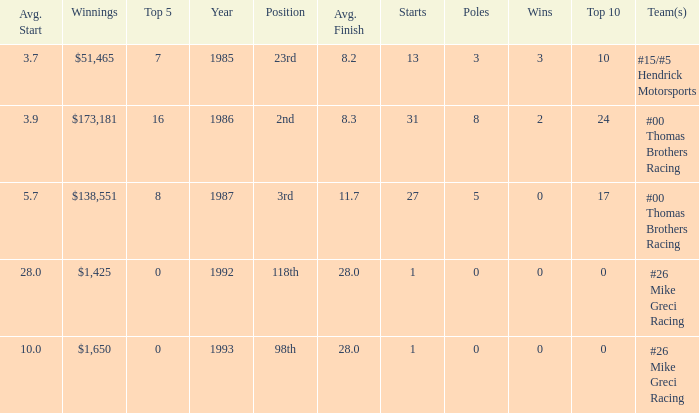What was the average finish the year Bodine finished 3rd? 11.7. 